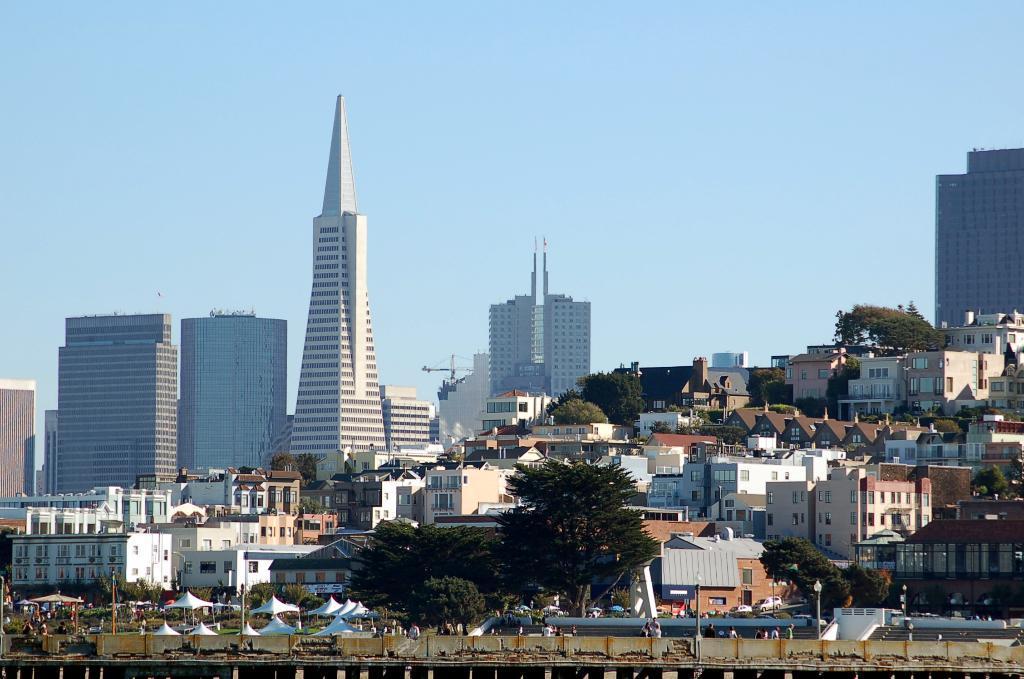How would you summarize this image in a sentence or two? In this image we can see some buildings, trees, people, poles and other objects. At the top of the image there is the sky. At the bottom of the image it looks like a bridge. 